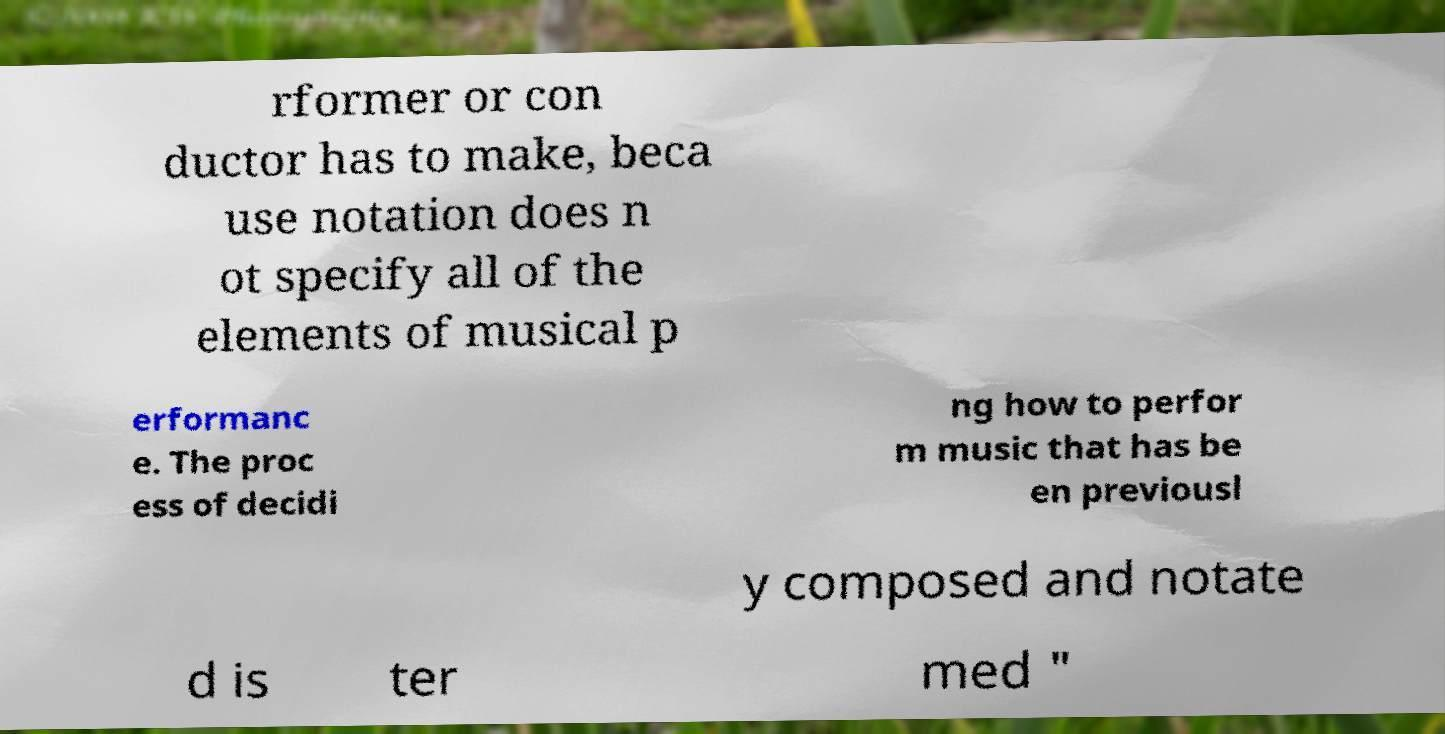For documentation purposes, I need the text within this image transcribed. Could you provide that? rformer or con ductor has to make, beca use notation does n ot specify all of the elements of musical p erformanc e. The proc ess of decidi ng how to perfor m music that has be en previousl y composed and notate d is ter med " 